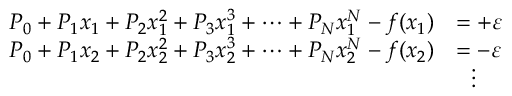<formula> <loc_0><loc_0><loc_500><loc_500>{ \begin{array} { r l } { P _ { 0 } + P _ { 1 } x _ { 1 } + P _ { 2 } x _ { 1 } ^ { 2 } + P _ { 3 } x _ { 1 } ^ { 3 } + \dots + P _ { N } x _ { 1 } ^ { N } - f ( x _ { 1 } ) } & { = + \varepsilon } \\ { P _ { 0 } + P _ { 1 } x _ { 2 } + P _ { 2 } x _ { 2 } ^ { 2 } + P _ { 3 } x _ { 2 } ^ { 3 } + \dots + P _ { N } x _ { 2 } ^ { N } - f ( x _ { 2 } ) } & { = - \varepsilon } \\ & { \quad v d o t s } \end{array} }</formula> 